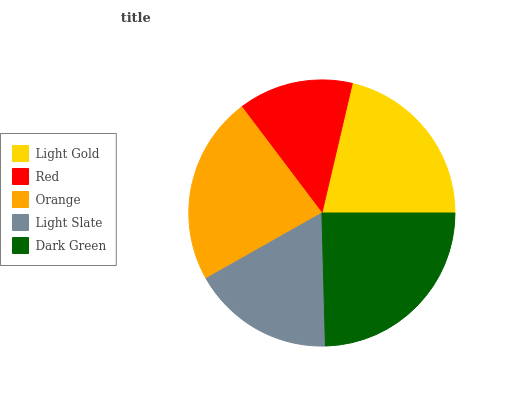Is Red the minimum?
Answer yes or no. Yes. Is Dark Green the maximum?
Answer yes or no. Yes. Is Orange the minimum?
Answer yes or no. No. Is Orange the maximum?
Answer yes or no. No. Is Orange greater than Red?
Answer yes or no. Yes. Is Red less than Orange?
Answer yes or no. Yes. Is Red greater than Orange?
Answer yes or no. No. Is Orange less than Red?
Answer yes or no. No. Is Light Gold the high median?
Answer yes or no. Yes. Is Light Gold the low median?
Answer yes or no. Yes. Is Red the high median?
Answer yes or no. No. Is Orange the low median?
Answer yes or no. No. 